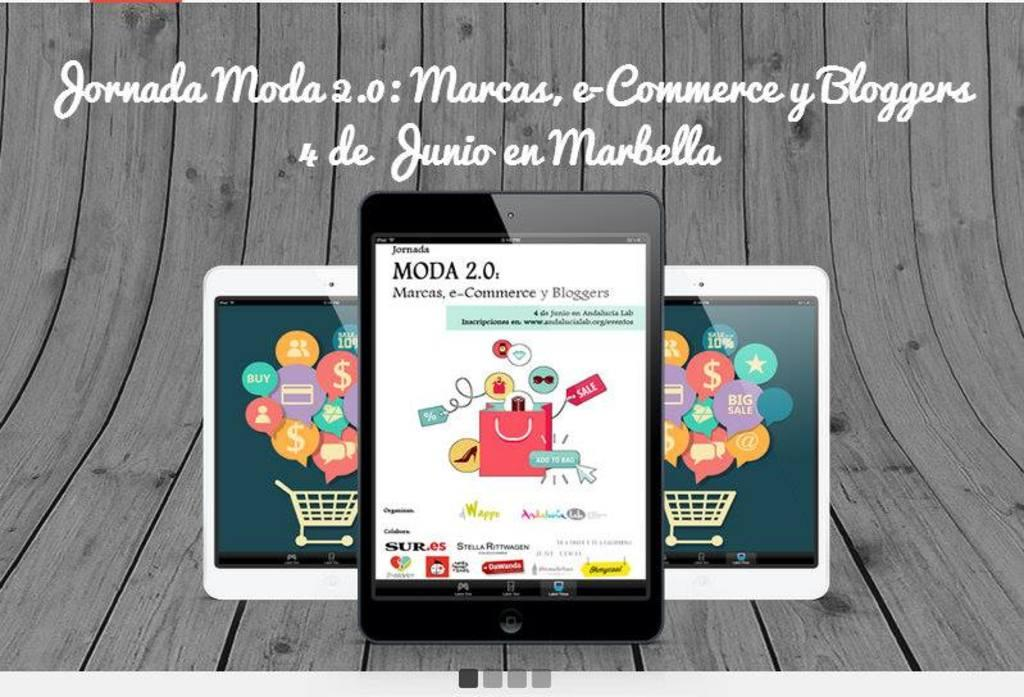<image>
Render a clear and concise summary of the photo. A phone in front of two others has the heading MODA 2.0 on the screen. 